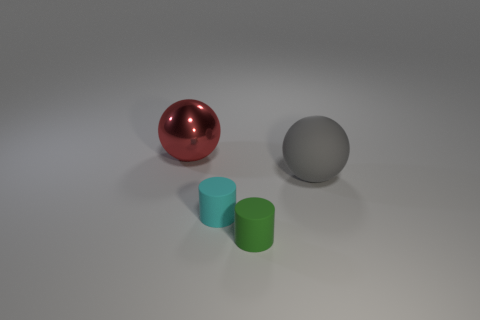Are there any objects in the image that appear to be touching or overlapping? From the perspective given in the image, none of the objects are touching or overlapping. Each object has its own distinct space on the flat surface, though the objects are arranged relatively close to one another.  What can you infer about the material of the objects from their appearance? Based on their appearance, the red sphere seems to have a reflective, glossy surface suggesting it could be made of polished metal or plastic. The large gray sphere has a matte finish hinting at a non-reflective material like stone or matte-painted plastic. The cylinders have a slightly shiny surface and could be made of a material like painted metal or plastic. 